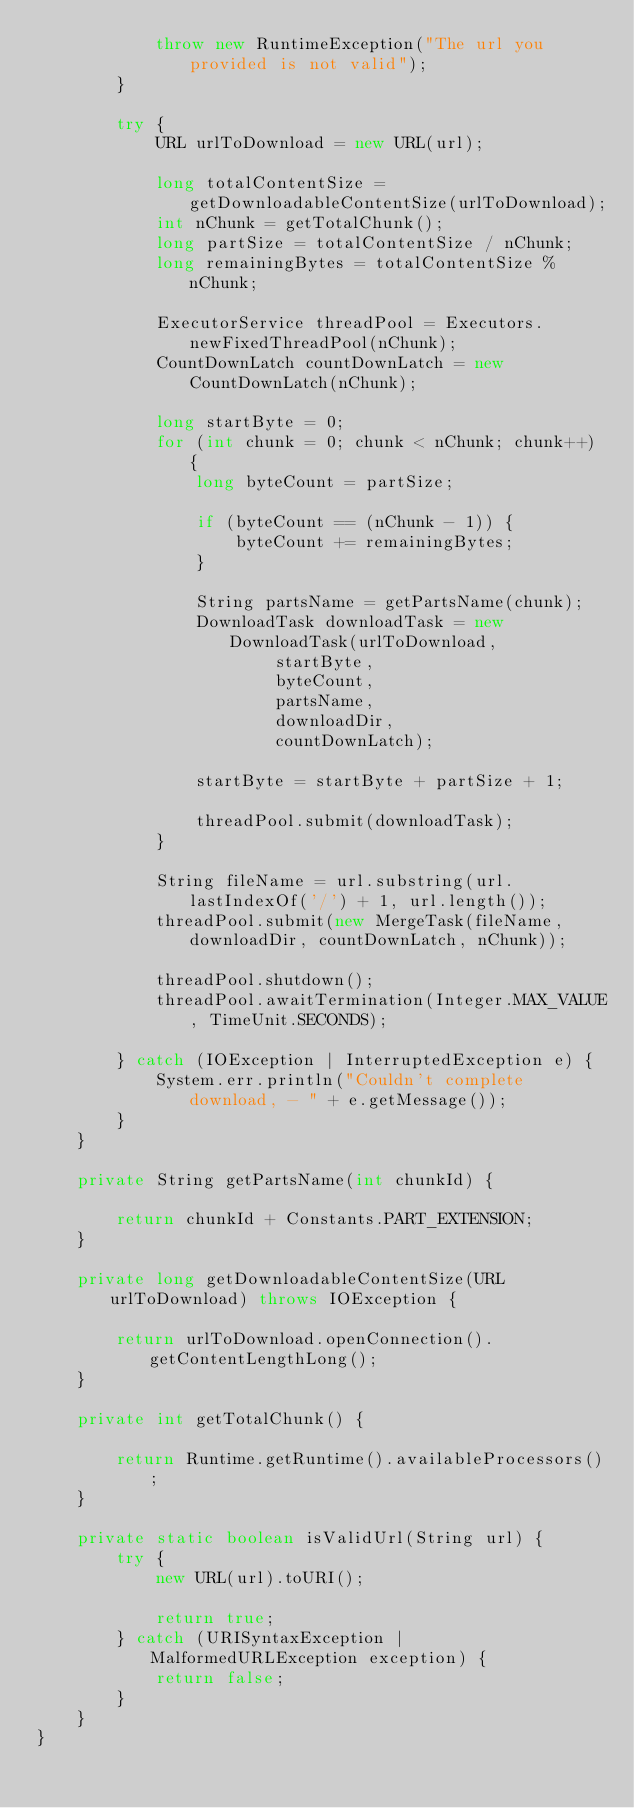Convert code to text. <code><loc_0><loc_0><loc_500><loc_500><_Java_>            throw new RuntimeException("The url you provided is not valid");
        }

        try {
            URL urlToDownload = new URL(url);

            long totalContentSize = getDownloadableContentSize(urlToDownload);
            int nChunk = getTotalChunk();
            long partSize = totalContentSize / nChunk;
            long remainingBytes = totalContentSize % nChunk;

            ExecutorService threadPool = Executors.newFixedThreadPool(nChunk);
            CountDownLatch countDownLatch = new CountDownLatch(nChunk);

            long startByte = 0;
            for (int chunk = 0; chunk < nChunk; chunk++) {
                long byteCount = partSize;

                if (byteCount == (nChunk - 1)) {
                    byteCount += remainingBytes;
                }

                String partsName = getPartsName(chunk);
                DownloadTask downloadTask = new DownloadTask(urlToDownload,
                        startByte,
                        byteCount,
                        partsName,
                        downloadDir,
                        countDownLatch);

                startByte = startByte + partSize + 1;

                threadPool.submit(downloadTask);
            }

            String fileName = url.substring(url.lastIndexOf('/') + 1, url.length());
            threadPool.submit(new MergeTask(fileName, downloadDir, countDownLatch, nChunk));

            threadPool.shutdown();
            threadPool.awaitTermination(Integer.MAX_VALUE, TimeUnit.SECONDS);

        } catch (IOException | InterruptedException e) {
            System.err.println("Couldn't complete download, - " + e.getMessage());
        }
    }

    private String getPartsName(int chunkId) {

        return chunkId + Constants.PART_EXTENSION;
    }

    private long getDownloadableContentSize(URL urlToDownload) throws IOException {

        return urlToDownload.openConnection().getContentLengthLong();
    }

    private int getTotalChunk() {

        return Runtime.getRuntime().availableProcessors();
    }

    private static boolean isValidUrl(String url) {
        try {
            new URL(url).toURI();

            return true;
        } catch (URISyntaxException | MalformedURLException exception) {
            return false;
        }
    }
}
</code> 